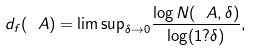Convert formula to latex. <formula><loc_0><loc_0><loc_500><loc_500>d _ { f } ( \ A ) = { \lim \sup } _ { \delta \rightarrow 0 } \frac { \log N ( \ A , \delta ) } { \log ( 1 ? \delta ) } ,</formula> 